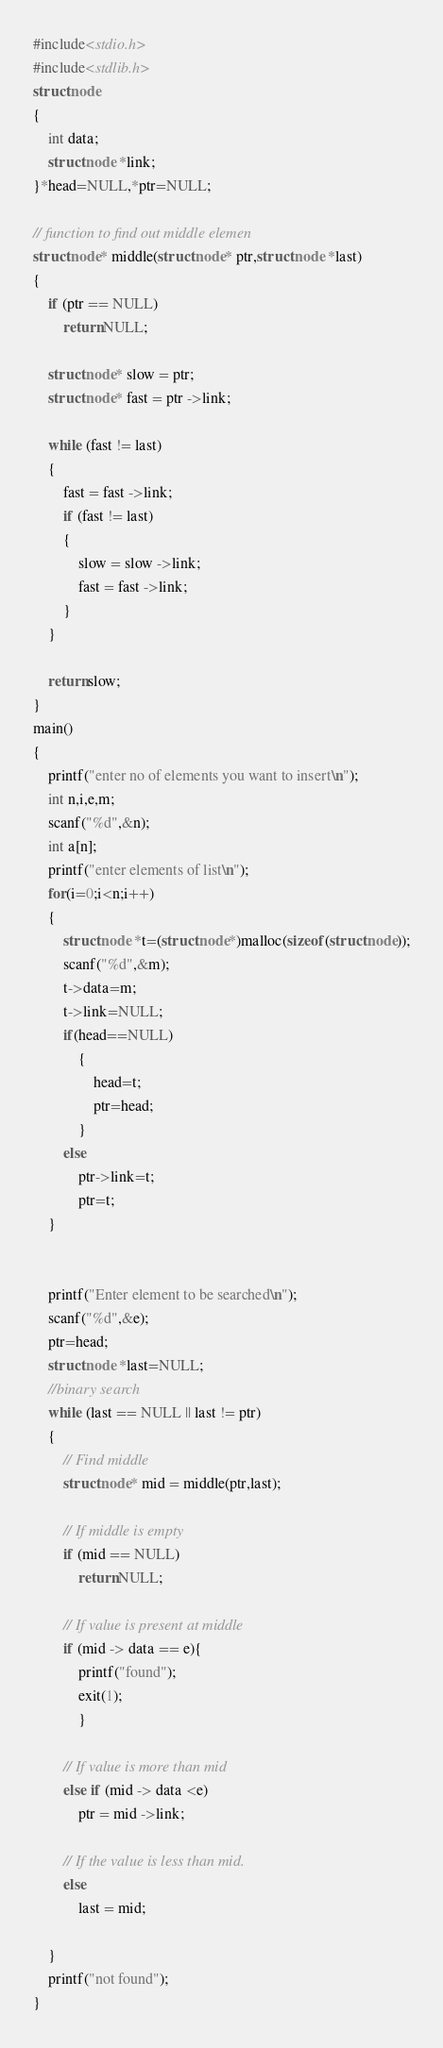<code> <loc_0><loc_0><loc_500><loc_500><_C_>#include<stdio.h>
#include<stdlib.h>
struct node
{
    int data;
    struct node *link;
}*head=NULL,*ptr=NULL;

// function to find out middle elemen
struct node* middle(struct node* ptr,struct node *last)
{
    if (ptr == NULL)
        return NULL;

    struct node* slow = ptr;
    struct node* fast = ptr ->link;

    while (fast != last)
    {
        fast = fast ->link;
        if (fast != last)
        {
            slow = slow ->link;
            fast = fast ->link;
        }
    }

    return slow;
}
main()
{
    printf("enter no of elements you want to insert\n");
    int n,i,e,m;
    scanf("%d",&n);
    int a[n];
    printf("enter elements of list\n");
    for(i=0;i<n;i++)
    {
        struct node *t=(struct node*)malloc(sizeof(struct node));
        scanf("%d",&m);
        t->data=m;
        t->link=NULL;
        if(head==NULL)
            {
                head=t;
                ptr=head;
            }
        else
            ptr->link=t;
            ptr=t;
    }


    printf("Enter element to be searched\n");
    scanf("%d",&e);
    ptr=head;
    struct node *last=NULL;
    //binary search
    while (last == NULL || last != ptr)
    {
        // Find middle
        struct node* mid = middle(ptr,last);

        // If middle is empty
        if (mid == NULL)
            return NULL;

        // If value is present at middle
        if (mid -> data == e){
            printf("found");
            exit(1);
            }

        // If value is more than mid
        else if (mid -> data <e)
            ptr = mid ->link;

        // If the value is less than mid.
        else
            last = mid;

    }
    printf("not found");
}
</code> 